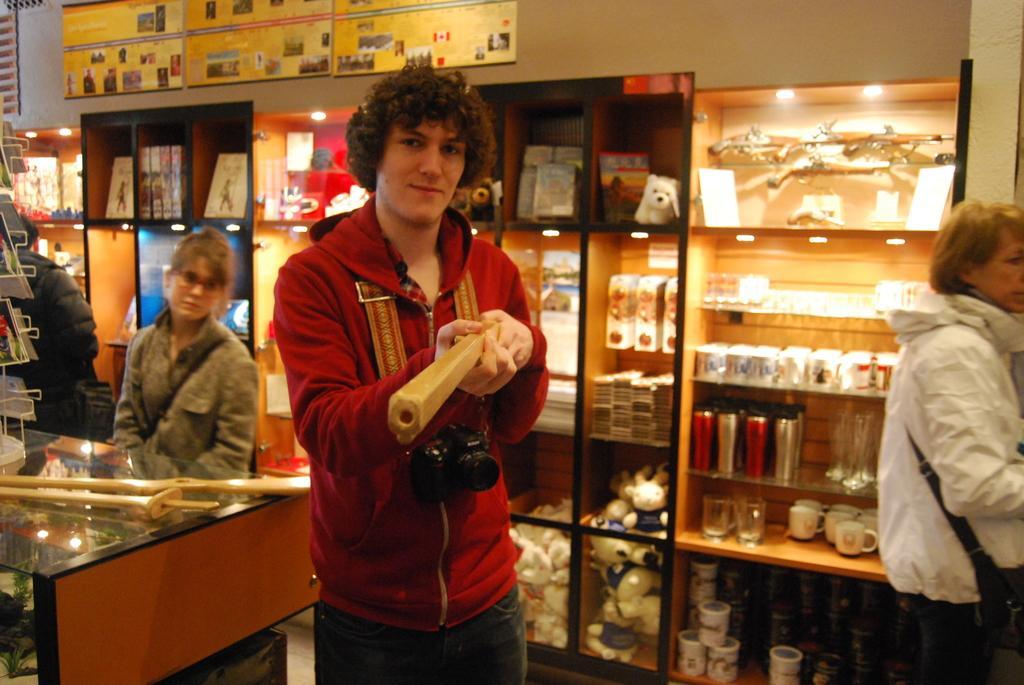Describe this image in one or two sentences. Here we can see three persons and he is holding an object with his hands. This is a table. In the background we can see racks, lights, books, toys, glasses, cups, and bottles. There are frames and this is wall. 